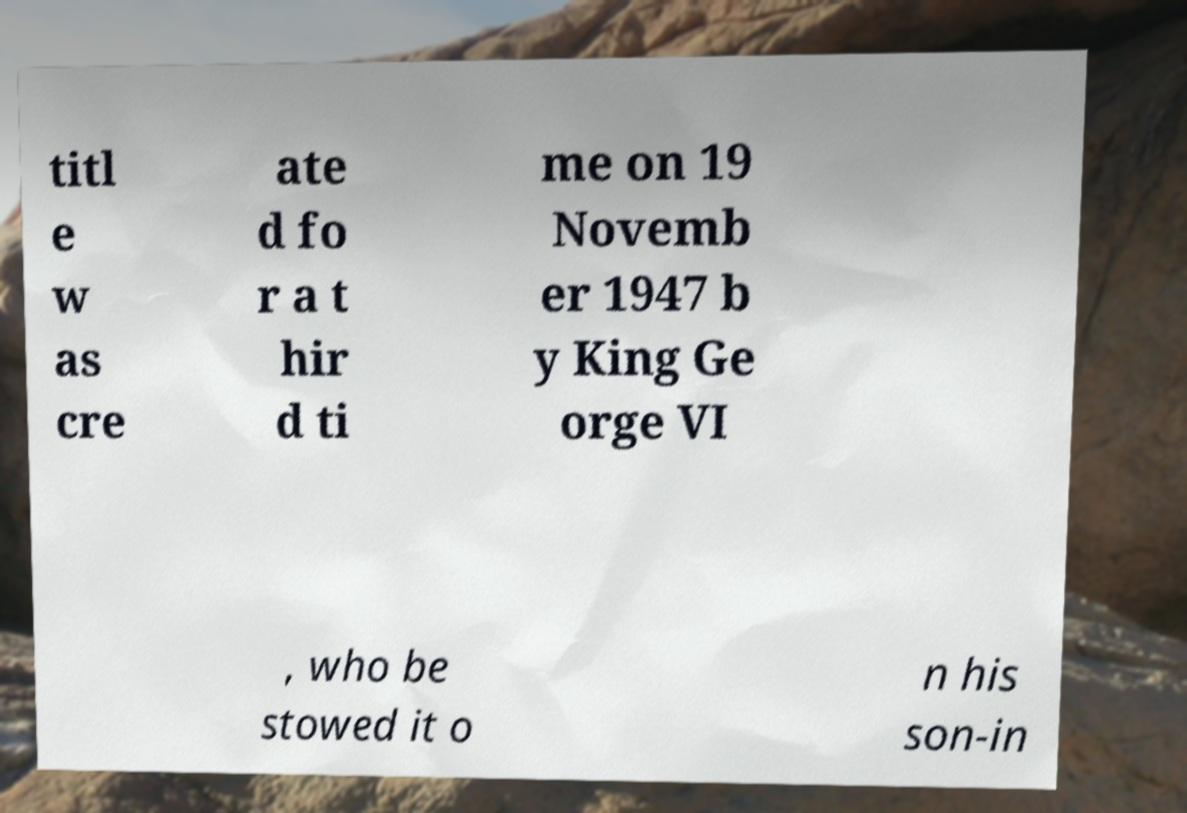Please identify and transcribe the text found in this image. titl e w as cre ate d fo r a t hir d ti me on 19 Novemb er 1947 b y King Ge orge VI , who be stowed it o n his son-in 